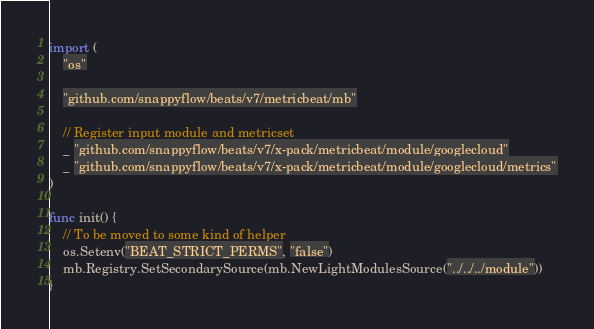<code> <loc_0><loc_0><loc_500><loc_500><_Go_>
import (
	"os"

	"github.com/snappyflow/beats/v7/metricbeat/mb"

	// Register input module and metricset
	_ "github.com/snappyflow/beats/v7/x-pack/metricbeat/module/googlecloud"
	_ "github.com/snappyflow/beats/v7/x-pack/metricbeat/module/googlecloud/metrics"
)

func init() {
	// To be moved to some kind of helper
	os.Setenv("BEAT_STRICT_PERMS", "false")
	mb.Registry.SetSecondarySource(mb.NewLightModulesSource("../../../module"))
}
</code> 